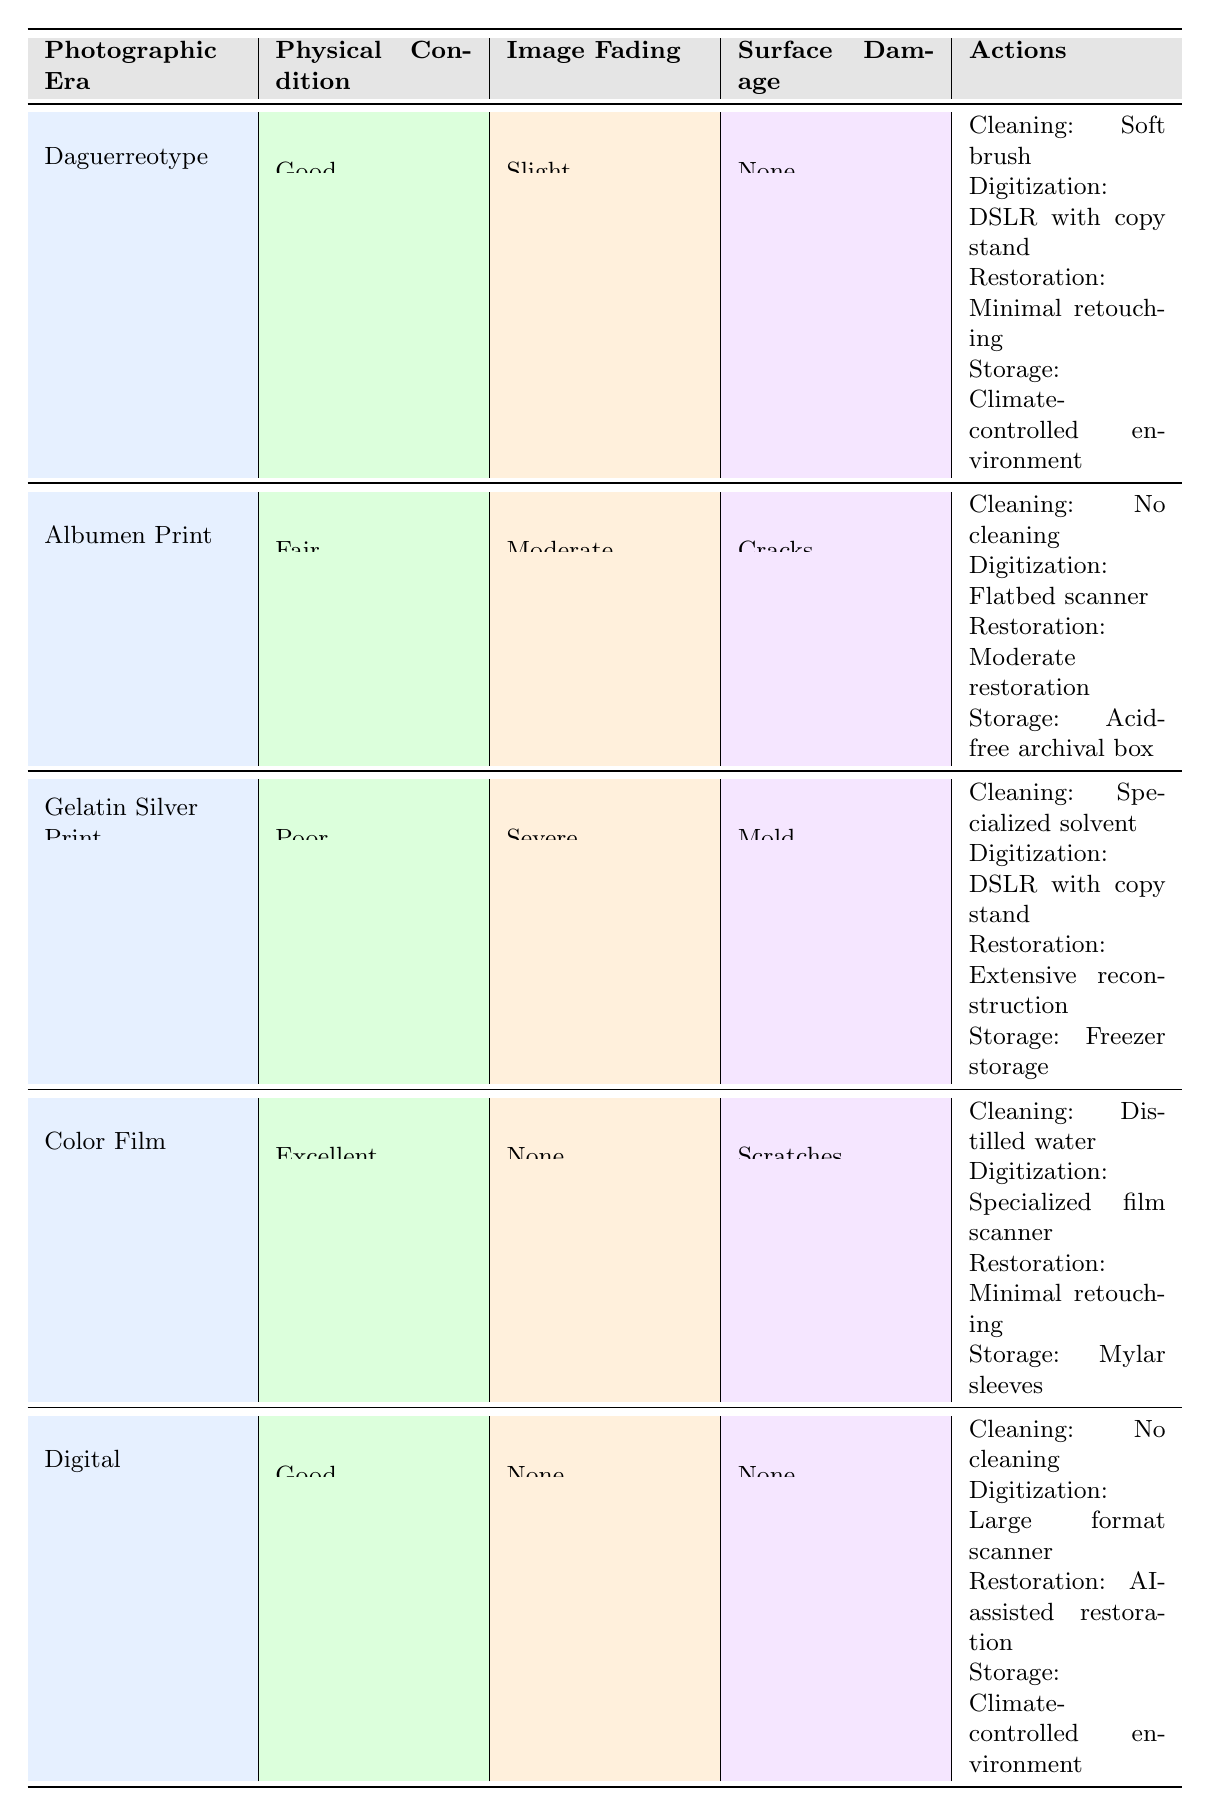What cleaning method is recommended for Gelatin Silver Prints in poor condition with severe fading and mold? According to the table, for Gelatin Silver Prints that are in poor condition, have severe fading, and show surface damage like mold, the recommended cleaning method is "Specialized solvent".
Answer: Specialized solvent What digitization technique is suggested for Digital photographs that are in good condition with no fading or surface damage? For Digital photographs that are in good condition with no fading and no surface damage, the suggested digitization technique is "Large format scanner".
Answer: Large format scanner How many different photographic eras are listed in the table? The table lists seven different photographic eras: Daguerreotype, Ambrotype, Tintype, Albumen Print, Gelatin Silver Print, Color Film, and Digital. This totals to seven eras.
Answer: Seven Is it true that the recommended storage for Albumen Prints in fair condition with moderate fading and cracks is Mylar sleeves? No, the recommended storage for Albumen Prints in fair condition with moderate fading and cracks is "Acid-free archival box", not Mylar sleeves.
Answer: No Which cleaning method is used for Color Film photographs in excellent condition with no fading and scratches? The recommended cleaning method for Color Film photographs that are in excellent condition with no fading and scratches is "Distilled water".
Answer: Distilled water What is the recommended digital restoration approach for Gelatin Silver Prints with severe fading and mold? The recommended digital restoration approach for Gelatin Silver Prints in poor condition with severe fading and mold is "Extensive reconstruction".
Answer: Extensive reconstruction If a Tintype is found in excellent condition with slight fading and no surface damage, which cleaning method should be applied? The table does not contain specific recommendations for Tintype; thus, there's no direct answer in the table for this exact scenario. Therefore, it cannot be answered based on the provided data.
Answer: Not applicable Which photographic era has the simplest cleaning method according to the table? The cleaning method with no cleaning is the simplest and it is applicable for Digital photographs in good condition, with no fading or surface damage.
Answer: No cleaning What is the digitization method for Albumen Prints that have cracks and moderate fading? For Albumen Prints that are in fair condition with moderate fading and cracks, the digitization method is "Flatbed scanner".
Answer: Flatbed scanner 